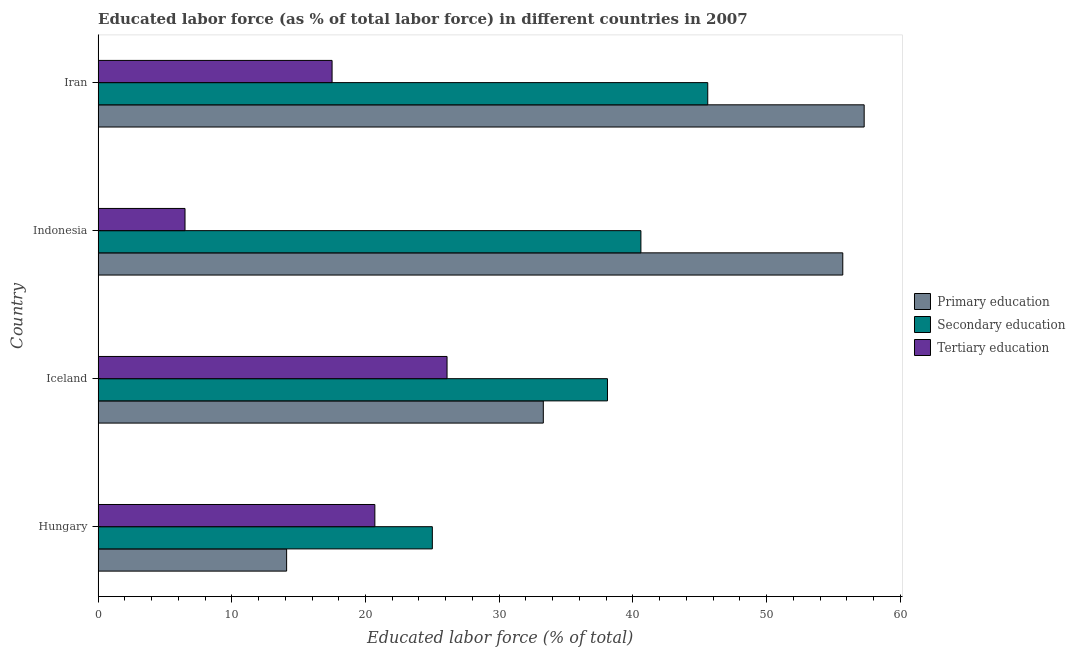How many groups of bars are there?
Ensure brevity in your answer.  4. Are the number of bars on each tick of the Y-axis equal?
Provide a short and direct response. Yes. How many bars are there on the 2nd tick from the top?
Give a very brief answer. 3. How many bars are there on the 4th tick from the bottom?
Provide a succinct answer. 3. What is the label of the 4th group of bars from the top?
Your response must be concise. Hungary. In how many cases, is the number of bars for a given country not equal to the number of legend labels?
Your answer should be compact. 0. What is the percentage of labor force who received primary education in Iceland?
Provide a succinct answer. 33.3. Across all countries, what is the maximum percentage of labor force who received primary education?
Give a very brief answer. 57.3. In which country was the percentage of labor force who received primary education maximum?
Make the answer very short. Iran. In which country was the percentage of labor force who received secondary education minimum?
Provide a short and direct response. Hungary. What is the total percentage of labor force who received tertiary education in the graph?
Your response must be concise. 70.8. What is the difference between the percentage of labor force who received tertiary education in Iran and the percentage of labor force who received primary education in Indonesia?
Give a very brief answer. -38.2. What is the average percentage of labor force who received primary education per country?
Provide a succinct answer. 40.1. What is the ratio of the percentage of labor force who received tertiary education in Hungary to that in Indonesia?
Provide a succinct answer. 3.19. Is the percentage of labor force who received tertiary education in Iceland less than that in Indonesia?
Your answer should be compact. No. What is the difference between the highest and the lowest percentage of labor force who received tertiary education?
Make the answer very short. 19.6. What does the 2nd bar from the top in Iran represents?
Make the answer very short. Secondary education. What does the 3rd bar from the bottom in Iran represents?
Provide a succinct answer. Tertiary education. Is it the case that in every country, the sum of the percentage of labor force who received primary education and percentage of labor force who received secondary education is greater than the percentage of labor force who received tertiary education?
Provide a succinct answer. Yes. How many bars are there?
Your response must be concise. 12. Are all the bars in the graph horizontal?
Ensure brevity in your answer.  Yes. Where does the legend appear in the graph?
Give a very brief answer. Center right. How many legend labels are there?
Keep it short and to the point. 3. What is the title of the graph?
Make the answer very short. Educated labor force (as % of total labor force) in different countries in 2007. Does "Oil" appear as one of the legend labels in the graph?
Ensure brevity in your answer.  No. What is the label or title of the X-axis?
Give a very brief answer. Educated labor force (% of total). What is the Educated labor force (% of total) of Primary education in Hungary?
Give a very brief answer. 14.1. What is the Educated labor force (% of total) in Tertiary education in Hungary?
Your answer should be compact. 20.7. What is the Educated labor force (% of total) in Primary education in Iceland?
Your answer should be very brief. 33.3. What is the Educated labor force (% of total) of Secondary education in Iceland?
Provide a succinct answer. 38.1. What is the Educated labor force (% of total) of Tertiary education in Iceland?
Provide a succinct answer. 26.1. What is the Educated labor force (% of total) of Primary education in Indonesia?
Make the answer very short. 55.7. What is the Educated labor force (% of total) of Secondary education in Indonesia?
Keep it short and to the point. 40.6. What is the Educated labor force (% of total) in Tertiary education in Indonesia?
Provide a short and direct response. 6.5. What is the Educated labor force (% of total) in Primary education in Iran?
Your answer should be very brief. 57.3. What is the Educated labor force (% of total) of Secondary education in Iran?
Your answer should be compact. 45.6. What is the Educated labor force (% of total) in Tertiary education in Iran?
Provide a succinct answer. 17.5. Across all countries, what is the maximum Educated labor force (% of total) of Primary education?
Provide a succinct answer. 57.3. Across all countries, what is the maximum Educated labor force (% of total) in Secondary education?
Offer a very short reply. 45.6. Across all countries, what is the maximum Educated labor force (% of total) in Tertiary education?
Your answer should be very brief. 26.1. Across all countries, what is the minimum Educated labor force (% of total) of Primary education?
Your answer should be compact. 14.1. Across all countries, what is the minimum Educated labor force (% of total) of Secondary education?
Give a very brief answer. 25. What is the total Educated labor force (% of total) in Primary education in the graph?
Your response must be concise. 160.4. What is the total Educated labor force (% of total) of Secondary education in the graph?
Offer a terse response. 149.3. What is the total Educated labor force (% of total) in Tertiary education in the graph?
Give a very brief answer. 70.8. What is the difference between the Educated labor force (% of total) of Primary education in Hungary and that in Iceland?
Your answer should be very brief. -19.2. What is the difference between the Educated labor force (% of total) in Secondary education in Hungary and that in Iceland?
Provide a short and direct response. -13.1. What is the difference between the Educated labor force (% of total) in Primary education in Hungary and that in Indonesia?
Provide a short and direct response. -41.6. What is the difference between the Educated labor force (% of total) in Secondary education in Hungary and that in Indonesia?
Make the answer very short. -15.6. What is the difference between the Educated labor force (% of total) in Primary education in Hungary and that in Iran?
Make the answer very short. -43.2. What is the difference between the Educated labor force (% of total) in Secondary education in Hungary and that in Iran?
Provide a succinct answer. -20.6. What is the difference between the Educated labor force (% of total) in Primary education in Iceland and that in Indonesia?
Offer a very short reply. -22.4. What is the difference between the Educated labor force (% of total) of Tertiary education in Iceland and that in Indonesia?
Offer a very short reply. 19.6. What is the difference between the Educated labor force (% of total) of Primary education in Iceland and that in Iran?
Offer a terse response. -24. What is the difference between the Educated labor force (% of total) in Secondary education in Iceland and that in Iran?
Ensure brevity in your answer.  -7.5. What is the difference between the Educated labor force (% of total) in Primary education in Hungary and the Educated labor force (% of total) in Secondary education in Iceland?
Make the answer very short. -24. What is the difference between the Educated labor force (% of total) in Primary education in Hungary and the Educated labor force (% of total) in Tertiary education in Iceland?
Your answer should be compact. -12. What is the difference between the Educated labor force (% of total) in Primary education in Hungary and the Educated labor force (% of total) in Secondary education in Indonesia?
Offer a terse response. -26.5. What is the difference between the Educated labor force (% of total) of Secondary education in Hungary and the Educated labor force (% of total) of Tertiary education in Indonesia?
Offer a very short reply. 18.5. What is the difference between the Educated labor force (% of total) in Primary education in Hungary and the Educated labor force (% of total) in Secondary education in Iran?
Give a very brief answer. -31.5. What is the difference between the Educated labor force (% of total) of Primary education in Hungary and the Educated labor force (% of total) of Tertiary education in Iran?
Keep it short and to the point. -3.4. What is the difference between the Educated labor force (% of total) of Primary education in Iceland and the Educated labor force (% of total) of Tertiary education in Indonesia?
Keep it short and to the point. 26.8. What is the difference between the Educated labor force (% of total) in Secondary education in Iceland and the Educated labor force (% of total) in Tertiary education in Indonesia?
Ensure brevity in your answer.  31.6. What is the difference between the Educated labor force (% of total) of Primary education in Iceland and the Educated labor force (% of total) of Secondary education in Iran?
Give a very brief answer. -12.3. What is the difference between the Educated labor force (% of total) in Secondary education in Iceland and the Educated labor force (% of total) in Tertiary education in Iran?
Provide a succinct answer. 20.6. What is the difference between the Educated labor force (% of total) of Primary education in Indonesia and the Educated labor force (% of total) of Tertiary education in Iran?
Ensure brevity in your answer.  38.2. What is the difference between the Educated labor force (% of total) in Secondary education in Indonesia and the Educated labor force (% of total) in Tertiary education in Iran?
Make the answer very short. 23.1. What is the average Educated labor force (% of total) of Primary education per country?
Your answer should be very brief. 40.1. What is the average Educated labor force (% of total) of Secondary education per country?
Your answer should be compact. 37.33. What is the difference between the Educated labor force (% of total) in Primary education and Educated labor force (% of total) in Secondary education in Hungary?
Your answer should be compact. -10.9. What is the difference between the Educated labor force (% of total) in Secondary education and Educated labor force (% of total) in Tertiary education in Hungary?
Provide a succinct answer. 4.3. What is the difference between the Educated labor force (% of total) of Primary education and Educated labor force (% of total) of Secondary education in Iceland?
Your answer should be compact. -4.8. What is the difference between the Educated labor force (% of total) in Secondary education and Educated labor force (% of total) in Tertiary education in Iceland?
Make the answer very short. 12. What is the difference between the Educated labor force (% of total) in Primary education and Educated labor force (% of total) in Tertiary education in Indonesia?
Your answer should be compact. 49.2. What is the difference between the Educated labor force (% of total) of Secondary education and Educated labor force (% of total) of Tertiary education in Indonesia?
Give a very brief answer. 34.1. What is the difference between the Educated labor force (% of total) of Primary education and Educated labor force (% of total) of Tertiary education in Iran?
Keep it short and to the point. 39.8. What is the difference between the Educated labor force (% of total) in Secondary education and Educated labor force (% of total) in Tertiary education in Iran?
Make the answer very short. 28.1. What is the ratio of the Educated labor force (% of total) of Primary education in Hungary to that in Iceland?
Provide a short and direct response. 0.42. What is the ratio of the Educated labor force (% of total) of Secondary education in Hungary to that in Iceland?
Provide a short and direct response. 0.66. What is the ratio of the Educated labor force (% of total) in Tertiary education in Hungary to that in Iceland?
Your answer should be compact. 0.79. What is the ratio of the Educated labor force (% of total) of Primary education in Hungary to that in Indonesia?
Make the answer very short. 0.25. What is the ratio of the Educated labor force (% of total) of Secondary education in Hungary to that in Indonesia?
Provide a short and direct response. 0.62. What is the ratio of the Educated labor force (% of total) in Tertiary education in Hungary to that in Indonesia?
Your answer should be compact. 3.18. What is the ratio of the Educated labor force (% of total) of Primary education in Hungary to that in Iran?
Offer a terse response. 0.25. What is the ratio of the Educated labor force (% of total) of Secondary education in Hungary to that in Iran?
Your response must be concise. 0.55. What is the ratio of the Educated labor force (% of total) in Tertiary education in Hungary to that in Iran?
Offer a very short reply. 1.18. What is the ratio of the Educated labor force (% of total) of Primary education in Iceland to that in Indonesia?
Offer a terse response. 0.6. What is the ratio of the Educated labor force (% of total) of Secondary education in Iceland to that in Indonesia?
Make the answer very short. 0.94. What is the ratio of the Educated labor force (% of total) of Tertiary education in Iceland to that in Indonesia?
Give a very brief answer. 4.02. What is the ratio of the Educated labor force (% of total) in Primary education in Iceland to that in Iran?
Provide a short and direct response. 0.58. What is the ratio of the Educated labor force (% of total) in Secondary education in Iceland to that in Iran?
Offer a terse response. 0.84. What is the ratio of the Educated labor force (% of total) of Tertiary education in Iceland to that in Iran?
Keep it short and to the point. 1.49. What is the ratio of the Educated labor force (% of total) of Primary education in Indonesia to that in Iran?
Your answer should be compact. 0.97. What is the ratio of the Educated labor force (% of total) in Secondary education in Indonesia to that in Iran?
Ensure brevity in your answer.  0.89. What is the ratio of the Educated labor force (% of total) of Tertiary education in Indonesia to that in Iran?
Ensure brevity in your answer.  0.37. What is the difference between the highest and the second highest Educated labor force (% of total) of Tertiary education?
Your response must be concise. 5.4. What is the difference between the highest and the lowest Educated labor force (% of total) of Primary education?
Your answer should be compact. 43.2. What is the difference between the highest and the lowest Educated labor force (% of total) in Secondary education?
Your response must be concise. 20.6. What is the difference between the highest and the lowest Educated labor force (% of total) in Tertiary education?
Provide a succinct answer. 19.6. 